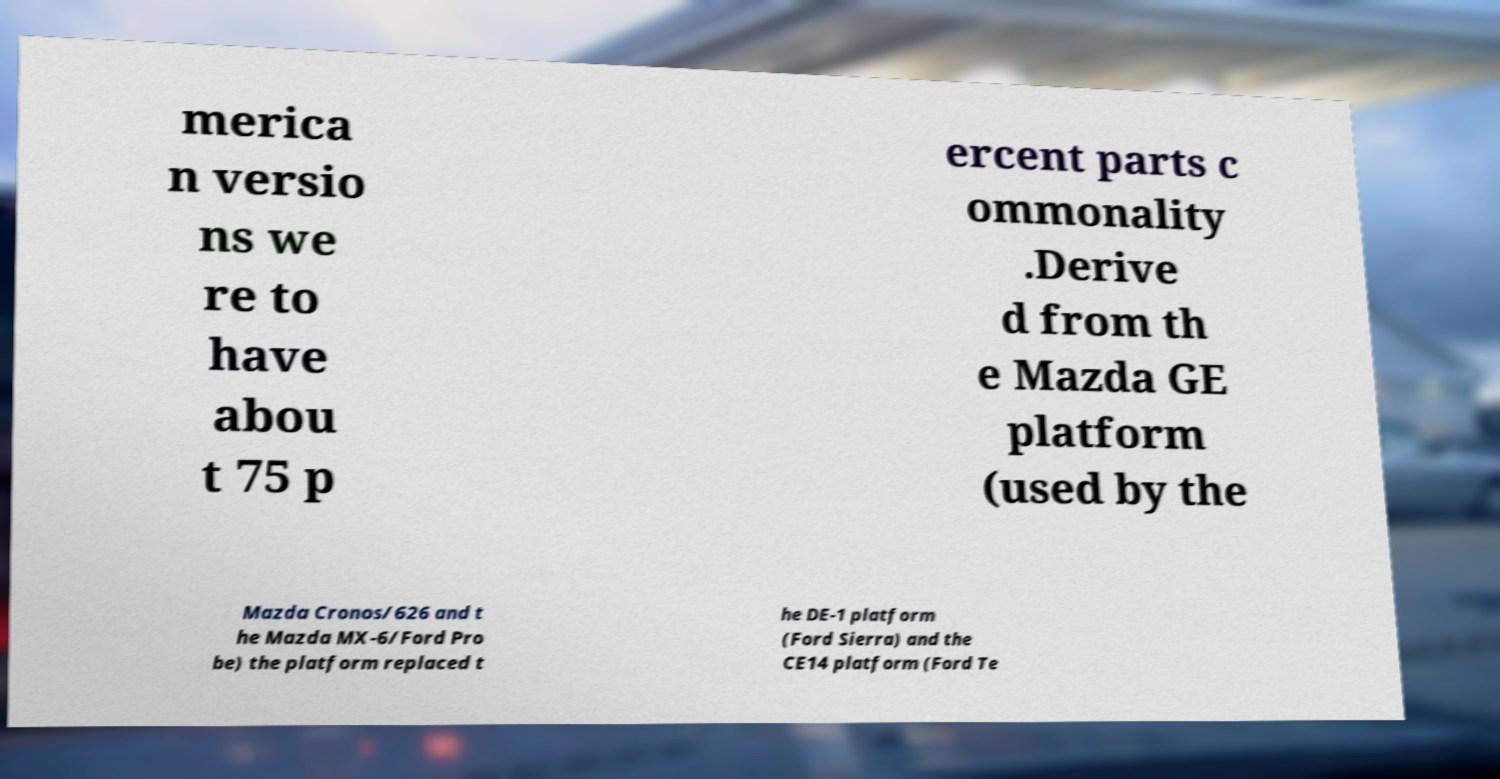Could you extract and type out the text from this image? merica n versio ns we re to have abou t 75 p ercent parts c ommonality .Derive d from th e Mazda GE platform (used by the Mazda Cronos/626 and t he Mazda MX-6/Ford Pro be) the platform replaced t he DE-1 platform (Ford Sierra) and the CE14 platform (Ford Te 